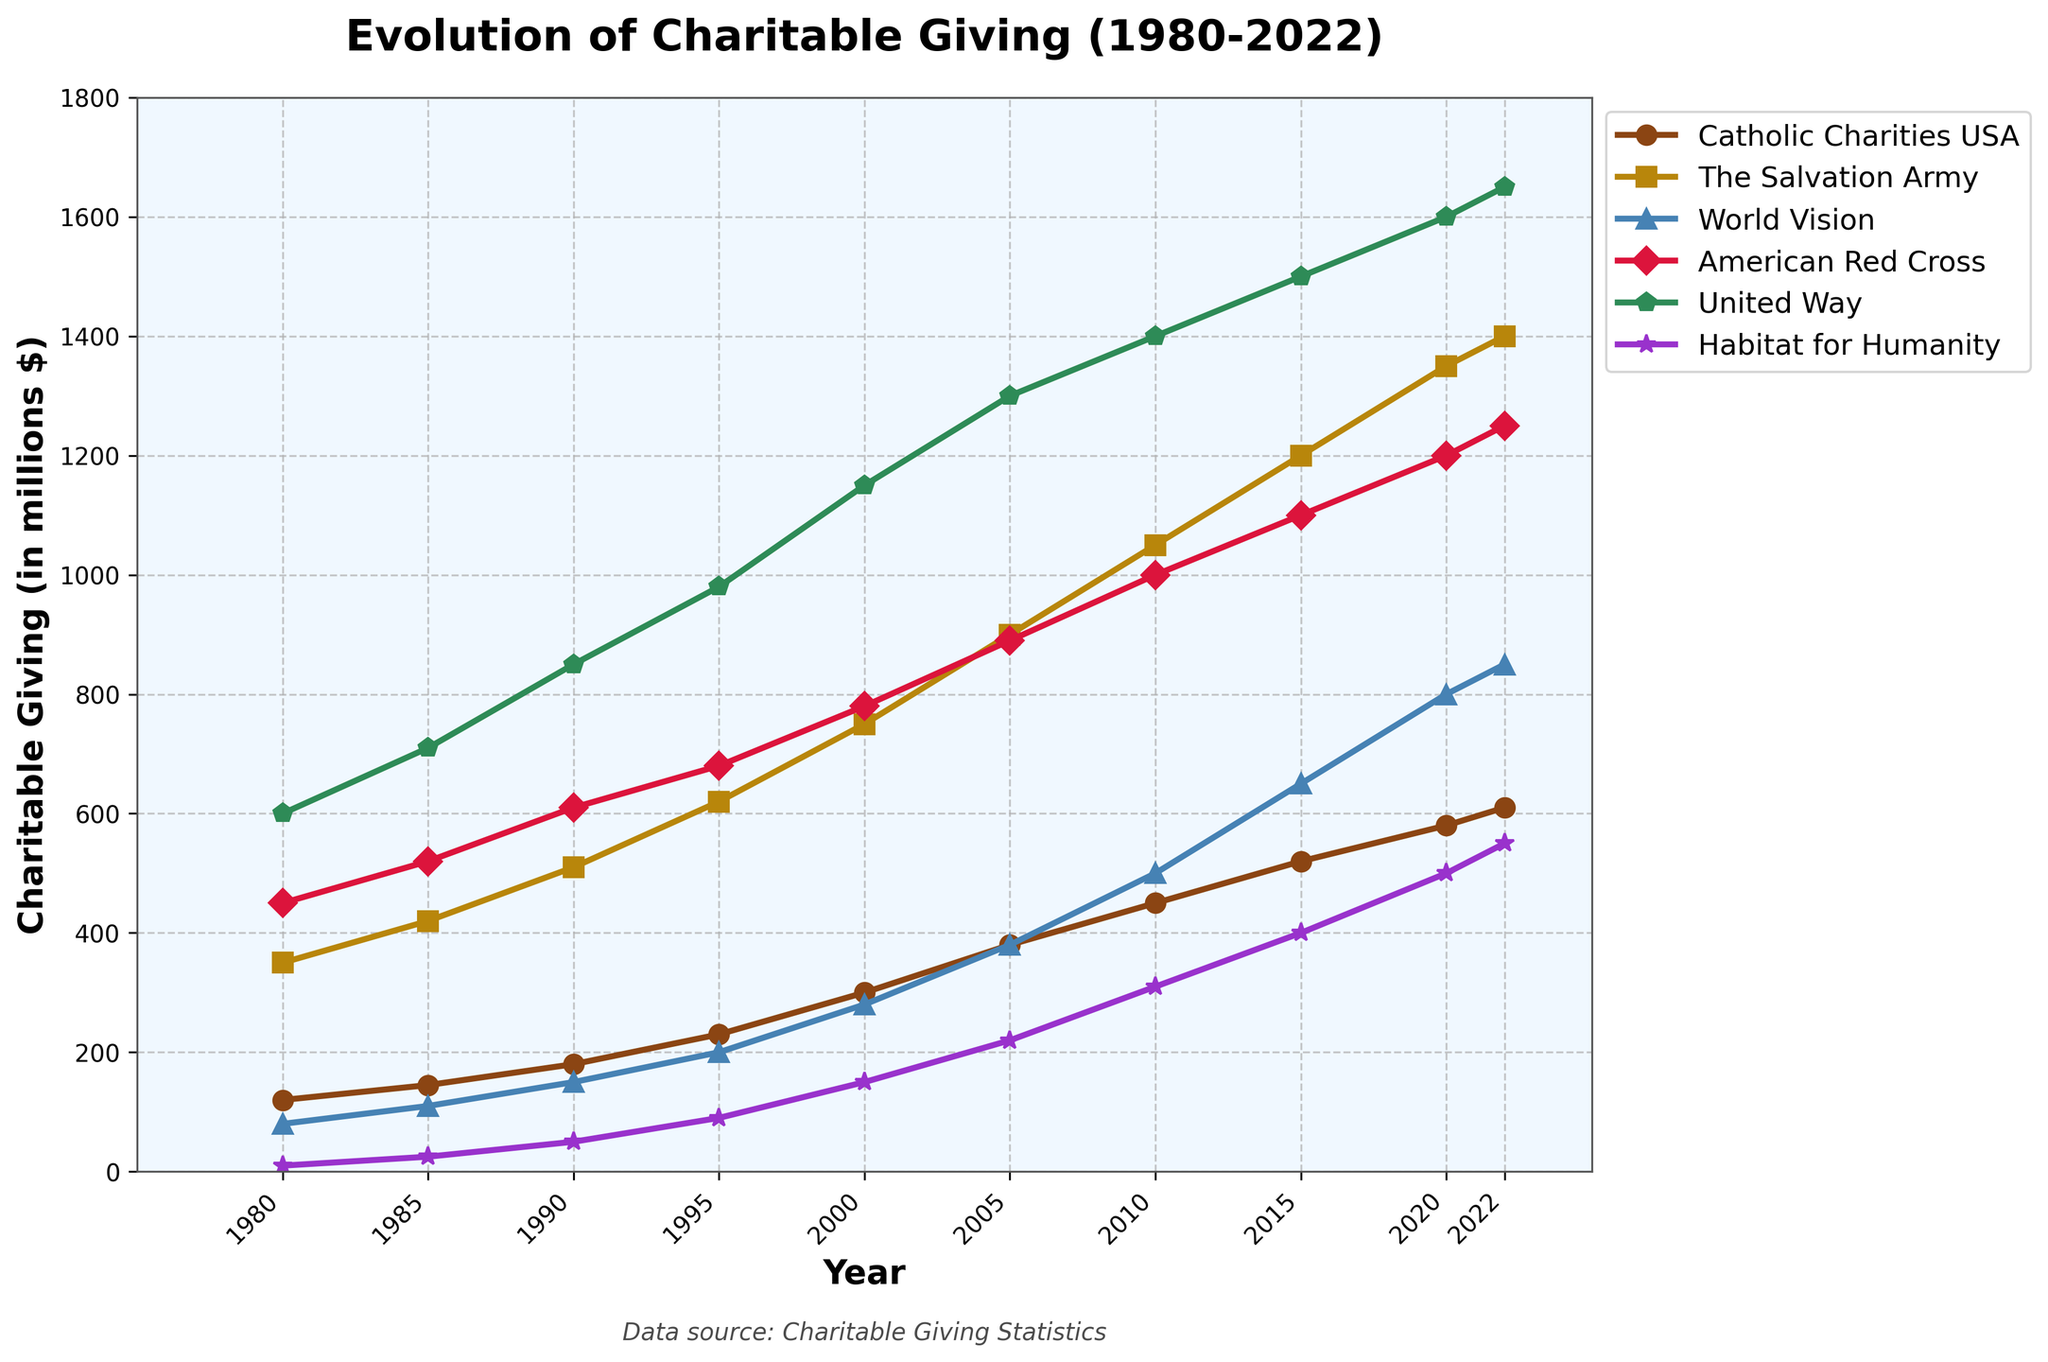Which organization received the highest charitable giving in 2020? To find the organization with the highest charitable giving in 2020, look at the 2020 data and identify the highest value. The American Red Cross received 1200 million dollars, which is the highest.
Answer: American Red Cross How much did charitable giving to The Salvation Army increase from 1980 to 2022? To calculate the increase, subtract the 1980 value from the 2022 value for The Salvation Army: 1400 - 350 = 1050 million dollars.
Answer: 1050 million dollars Which organization had the smallest increase in charitable giving from 1980 to 2022? Calculate the differences in giving for each organization from 1980 to 2022 and compare them. Habitat for Humanity had the smallest increase from 10 to 550, an increase of 540 million dollars.
Answer: Habitat for Humanity By how much did charitable giving to World Vision change from 2000 to 2005, and how does it compare to the change in giving to the United Way during the same period? Calculate the difference for World Vision (380 - 280 = 100 million dollars) and for United Way (1300 - 1150 = 150 million dollars). World Vision increased by 100 million, and United Way by 150 million, showing that United Way's increase was 50 million higher.
Answer: World Vision increased by 100 million dollars; United Way increased by 150 million dollars, which is 50 million dollars more Between which years did Catholic Charities USA see the largest increase in charitable giving? Review the increments between all adjacent years for Catholic Charities USA. The jump between 1995 to 2000 was the largest, from 230 to 300 million dollars, which is an increase of 70 million dollars.
Answer: Between 1995 and 2000 In which year did charitable giving to Habitat for Humanity first exceed 400 million dollars? Look at the values for Habitat for Humanity across the years. Habitat for Humanity first exceeded 400 million dollars in 2015 when it reached 400 million dollars.
Answer: 2015 What was the total charitable giving to faith-based organizations (Catholic Charities USA, The Salvation Army, World Vision) in 1990? Sum the values for these three organizations in 1990: 180 (Catholic Charities USA) + 510 (The Salvation Army) + 150 (World Vision) = 840 million dollars.
Answer: 840 million dollars Which two organizations had nearly equal charitable giving in 2022, and what is the approximate value? Compare the values for 2022 and find the closest match. The American Red Cross (1250) and World Vision (850) have close figures around 1250 million dollars.
Answer: American Red Cross and World Vision; approximately 1250 and 850 million dollars How did charitable giving to the American Red Cross and United Way compare in 1980 and 2022, respectively? Compare the 1980 values (450 for American Red Cross and 600 for United Way) and the 2022 values (1250 for American Red Cross and 1650 for United Way). Both years, United Way had higher charitable giving than the American Red Cross.
Answer: United Way had higher giving in both 1980 and 2022 Which organization saw the largest relative increase in charitable giving from 1980 to 2022? Calculate the percentage increase: [(2022 value - 1980 value) / 1980 value] * 100 for all organizations. The Salvation Army had the largest relative increase, from 350 to 1400 million dollars.
Answer: The Salvation Army 